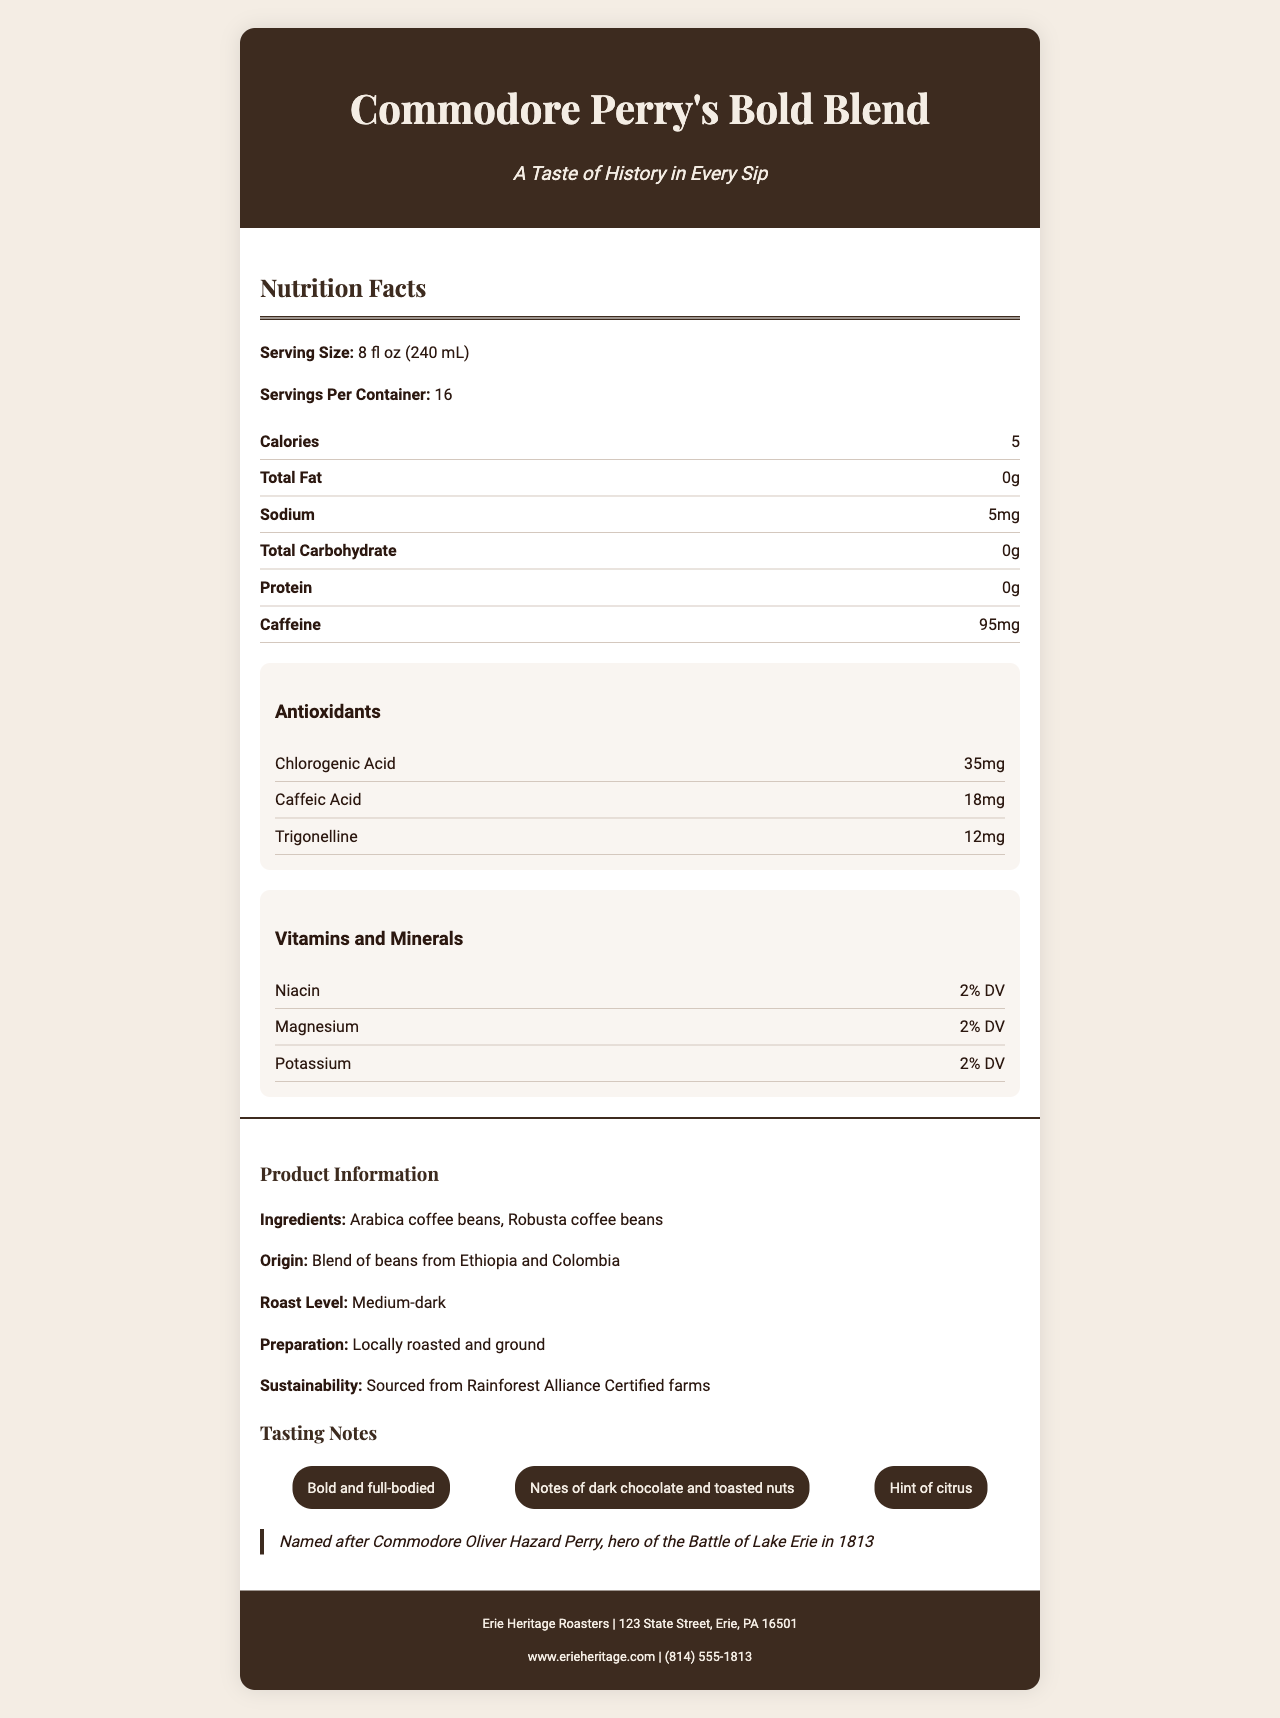which vitamins and minerals are present in the coffee blend? The vitamins and minerals section lists Niacin, Magnesium, and Potassium.
Answer: Niacin, Magnesium, Potassium What is the caffeine content per serving? The nutrition facts state that the caffeine content per serving is 95 mg.
Answer: 95 mg Name one of the tasting notes mentioned in the document. Under the tasting notes section, "Notes of dark chocolate and toasted nuts" and "Hint of citrus" are mentioned.
Answer: Notes of dark chocolate and toasted nuts, Hint of citrus What is the primary historical context associated with the coffee blend's name? The historical context section states that the blend is named after Commodore Oliver Hazard Perry, hero of the Battle of Lake Erie in 1813.
Answer: Named after Commodore Oliver Hazard Perry, hero of the Battle of Lake Erie in 1813 How many servings per container? The nutrition facts state that there are 16 servings per container.
Answer: 16 What is the origin of the coffee beans? A. Brazil B. Ethiopia and Colombia C. Peru The document mentions that the blend is a combination of beans from Ethiopia and Colombia.
Answer: B What is the roast level of this coffee blend? A. Light B. Medium-dark C. Dark The document specifies that the roast level is Medium-dark.
Answer: B Is the bag packaging recyclable? The packaging section indicates that the bag is recyclable.
Answer: Yes Summarize the main idea of this document. The document includes extensive information on the coffee's nutritional content, historical inspiration, tasting notes, ingredients, and sustainability.
Answer: The document provides nutritional information and product details for "Commodore Perry's Bold Blend," a specialty coffee blend named after a historical figure, enriched with antioxidants and vitamins, and sourced sustainably. Can you confirm if the company offers decaffeinated options? The document does not provide any details about decaffeinated options.
Answer: Not enough information 